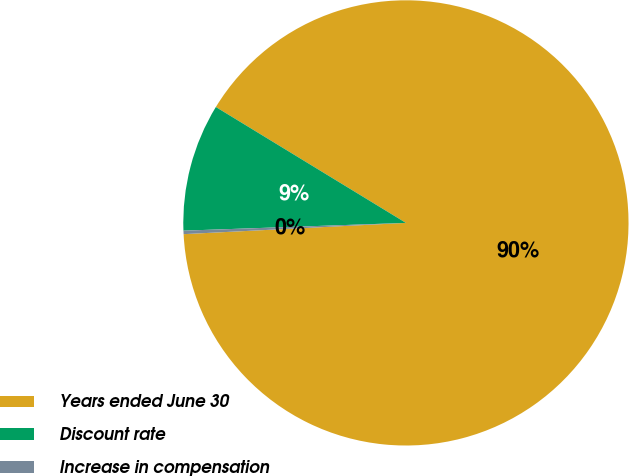Convert chart. <chart><loc_0><loc_0><loc_500><loc_500><pie_chart><fcel>Years ended June 30<fcel>Discount rate<fcel>Increase in compensation<nl><fcel>90.48%<fcel>9.27%<fcel>0.25%<nl></chart> 